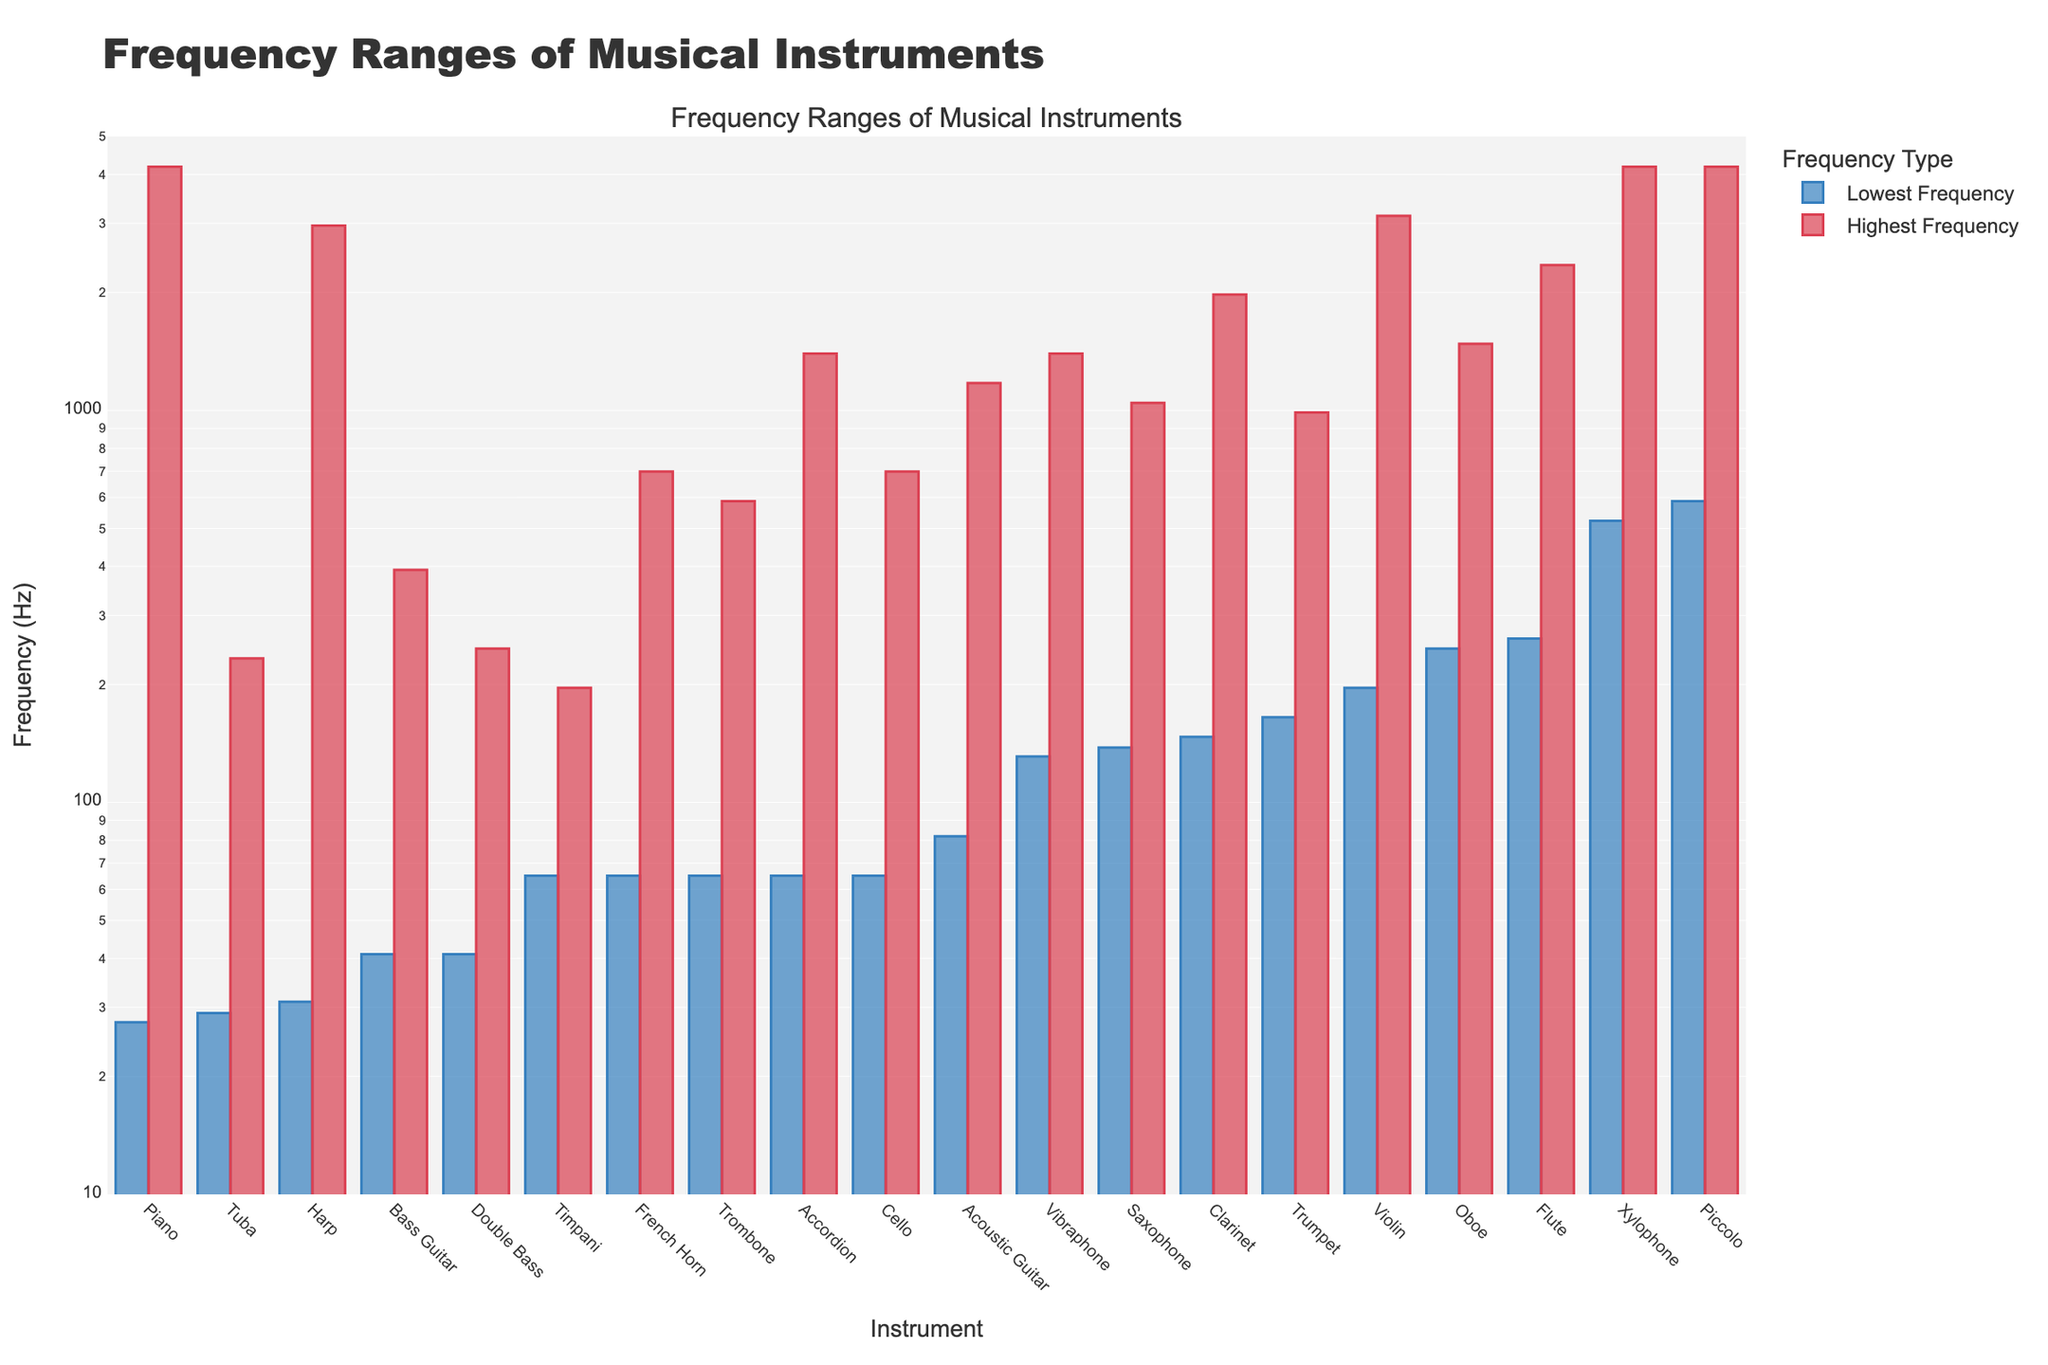Which instrument has the lowest minimum frequency? By observing the highest bar on the left side, the instrument with the lowest minimum frequency is evident. The Piano has the lowest minimum frequency among the displayed instruments.
Answer: Piano Compare the frequency range of the Bass Guitar and Violin. To find the discrepancy between the two instruments, examine the corresponding heights of the blue and red bars for each. The Bass Guitar ranges from 41 to 392 Hz, while the Violin ranges from 196 to 3136 Hz.
Answer: Bass Guitar: 41-392 Hz, Violin: 196-3136 Hz What is the frequency range of the Trumpet? Check the height of both the blue and red bars for frequency boundaries. The Trumpet's frequency ranges from 165 to 988 Hz.
Answer: 165-988 Hz Which instrument has a higher lowest frequency, the Clarinet or the Saxophone? Compare the height of the blue bars for both the Clarinet and the Saxophone. The Saxophone has a higher lowest frequency (138 Hz) compared to the Clarinet (147 Hz).
Answer: Clarinet Which instruments have maximum frequencies higher than 2000 Hz? Identify the instruments with tall red bars extending above 2000 Hz. The instruments with maximum frequencies above 2000 Hz are Piano, Violin, Piccolo, and Xylophone.
Answer: Piano, Violin, Piccolo, Xylophone What's the frequency range difference between the Accordion and Vibraphone? Compute the range for each (highest - lowest) and then find their difference. Accordion: 1397 - 65 = 1332 Hz, Vibraphone: 1397 - 131 = 1266 Hz. Difference = 1332 - 1266 = 66 Hz.
Answer: 66 Hz Which instrument has the smallest frequency range? Determine this by subtracting the lowest frequency from the highest for each instrument and identifying the smallest value. The Timpani has the smallest frequency range (196 - 65 = 131 Hz).
Answer: Timpani Compare the maximum frequencies of the Oboe and Flute. Which one is higher? Observe the height of the red bars corresponding to the Oboe and the Flute. The Flute has a higher maximum frequency (2349 Hz) than the Oboe (1480 Hz).
Answer: Flute 